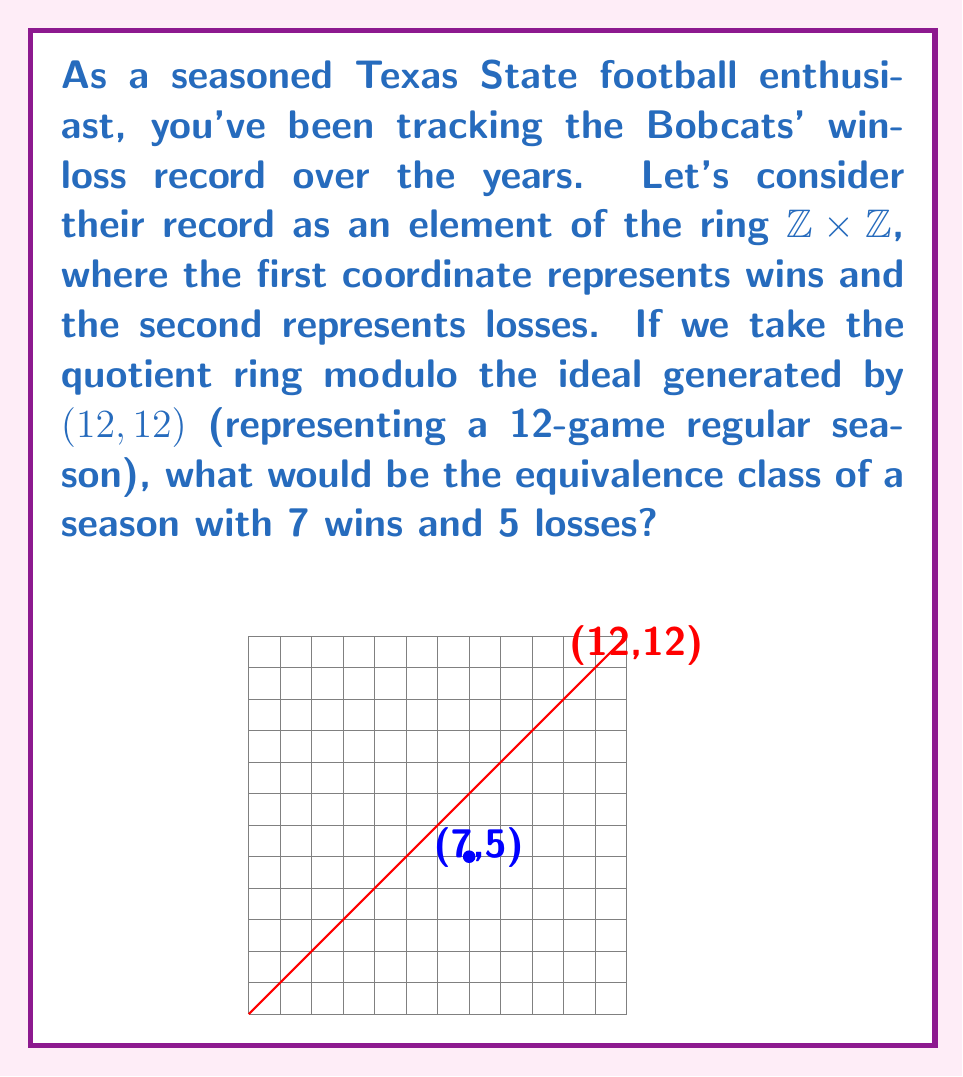Can you answer this question? Let's approach this step-by-step:

1) We're working in the ring $R = \mathbb{Z} \times \mathbb{Z}$, with the ideal $I = \langle(12,12)\rangle$.

2) The quotient ring $R/I$ consists of equivalence classes $[(a,b)]$, where $(a,b) \in R$.

3) Two elements $(a,b)$ and $(c,d)$ are in the same equivalence class if and only if their difference is in the ideal $I$. That is, if $(a-c,b-d) = k(12,12)$ for some integer $k$.

4) For our season with 7 wins and 5 losses, we're looking for the equivalence class of $(7,5)$.

5) To find this, we need to find the "standard" representative of this class. We can do this by subtracting multiples of $(12,12)$ until we get a pair where both coordinates are between 0 and 11 (inclusive).

6) In this case, $(7,5)$ is already in this range, so it is its own standard representative.

7) Therefore, the equivalence class of $(7,5)$ in $R/I$ is $[(7,5)]$.
Answer: $[(7,5)]$ 